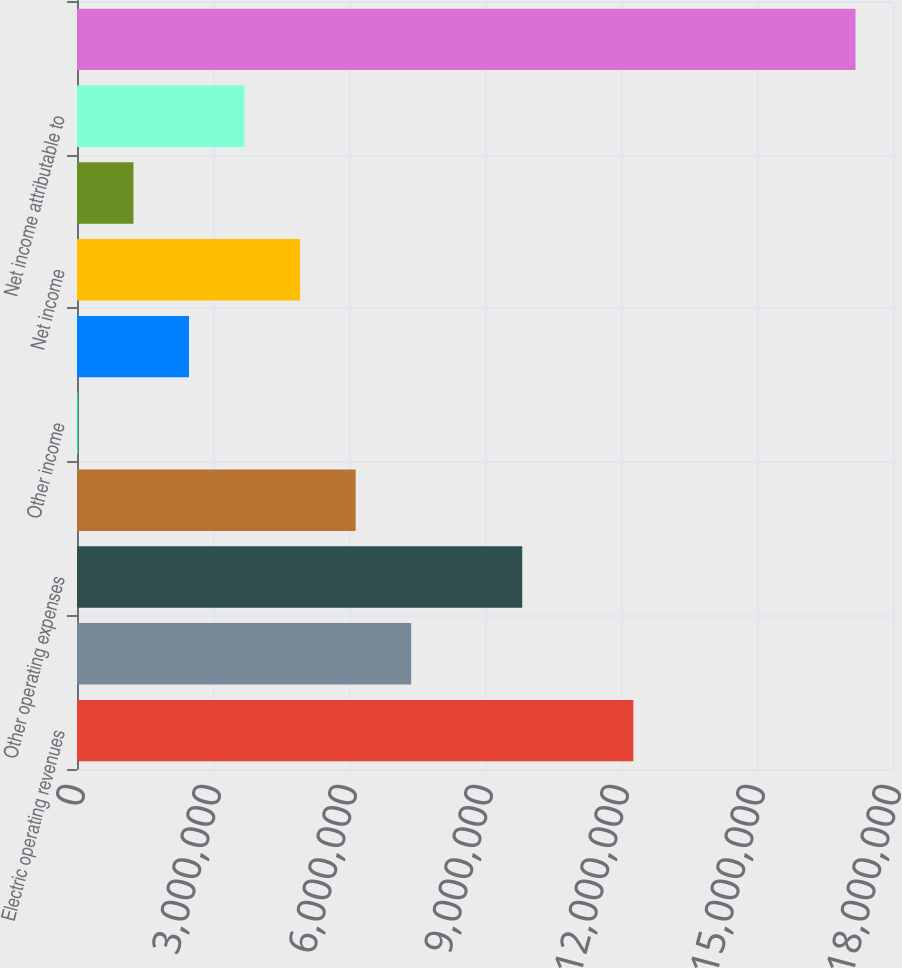<chart> <loc_0><loc_0><loc_500><loc_500><bar_chart><fcel>Electric operating revenues<fcel>Fuel and purchased power costs<fcel>Other operating expenses<fcel>Operating income<fcel>Other income<fcel>Interest expense - net of<fcel>Net income<fcel>Less Net income attributable<fcel>Net income attributable to<fcel>Total assets<nl><fcel>1.22719e+07<fcel>7.37118e+06<fcel>9.82153e+06<fcel>6.14601e+06<fcel>20138<fcel>2.47049e+06<fcel>4.92083e+06<fcel>1.24531e+06<fcel>3.69566e+06<fcel>1.71726e+07<nl></chart> 